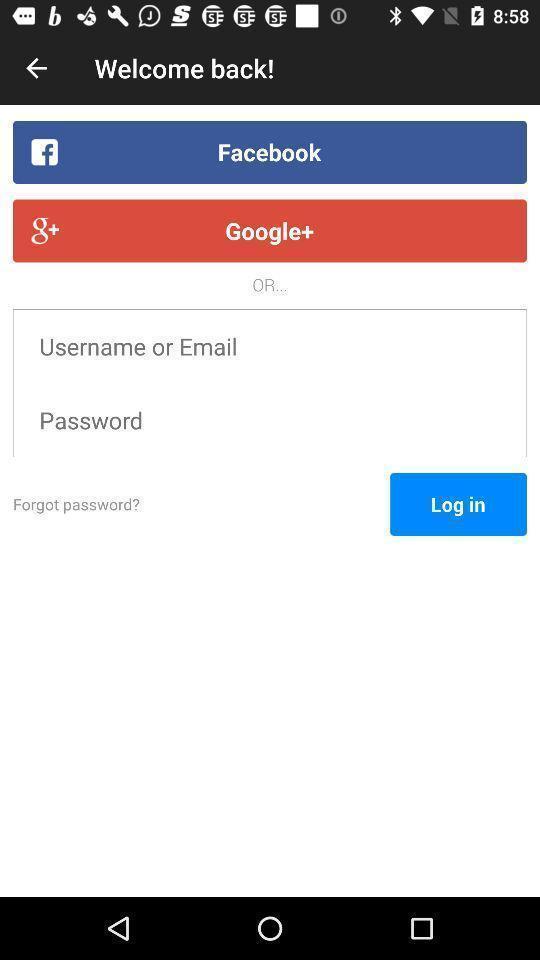Describe the visual elements of this screenshot. Login page to get the access from application. 